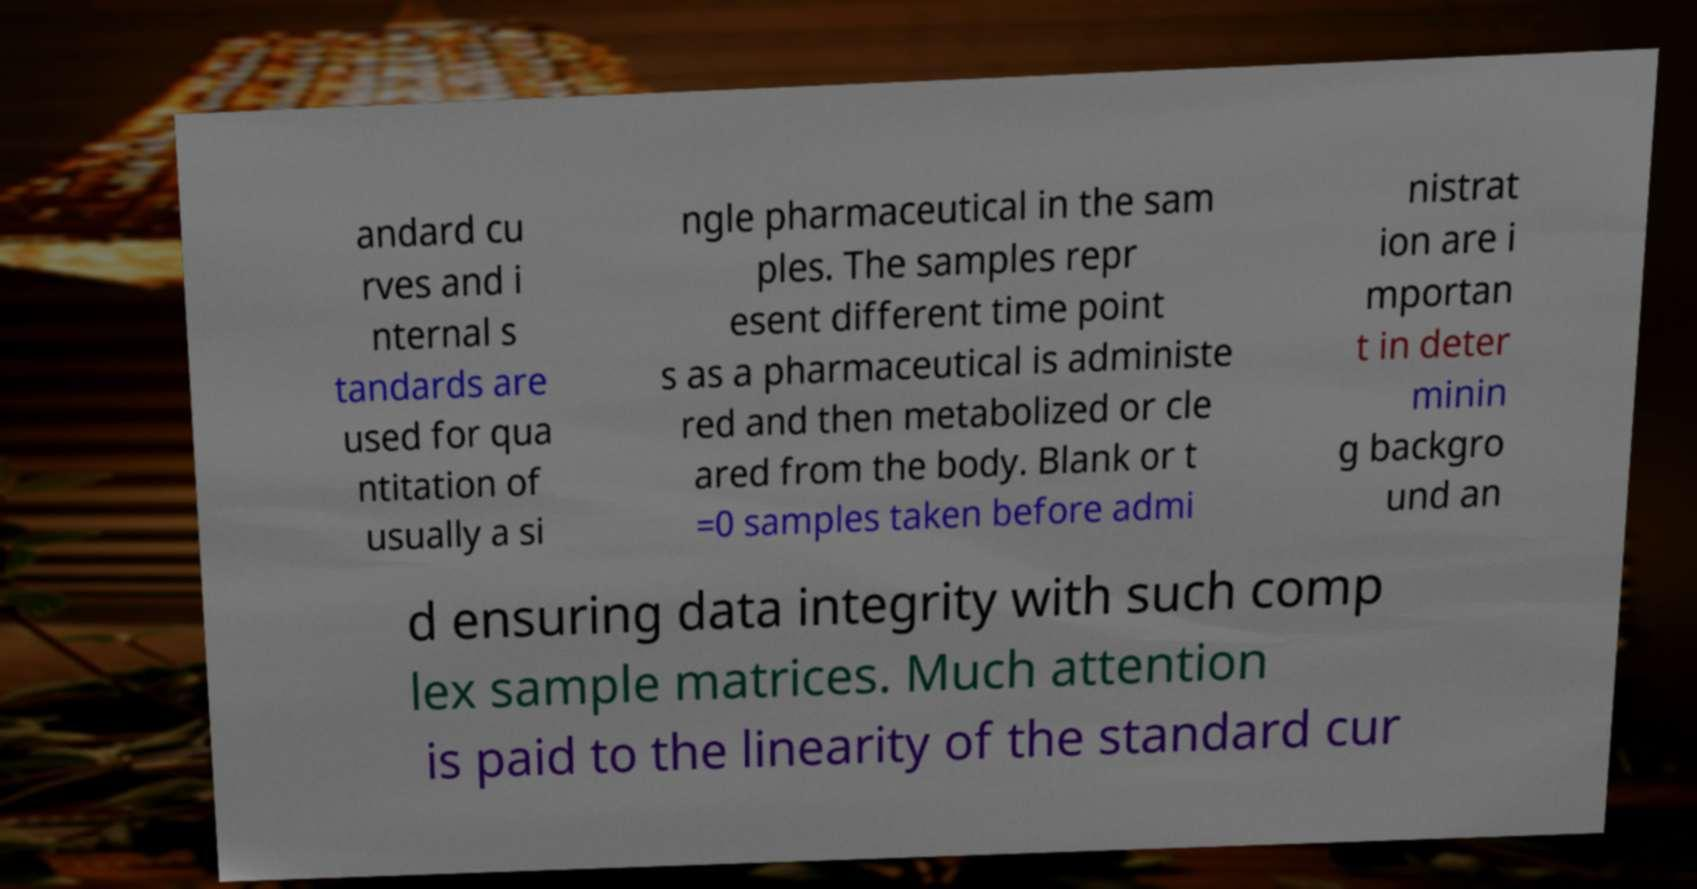Could you assist in decoding the text presented in this image and type it out clearly? andard cu rves and i nternal s tandards are used for qua ntitation of usually a si ngle pharmaceutical in the sam ples. The samples repr esent different time point s as a pharmaceutical is administe red and then metabolized or cle ared from the body. Blank or t =0 samples taken before admi nistrat ion are i mportan t in deter minin g backgro und an d ensuring data integrity with such comp lex sample matrices. Much attention is paid to the linearity of the standard cur 